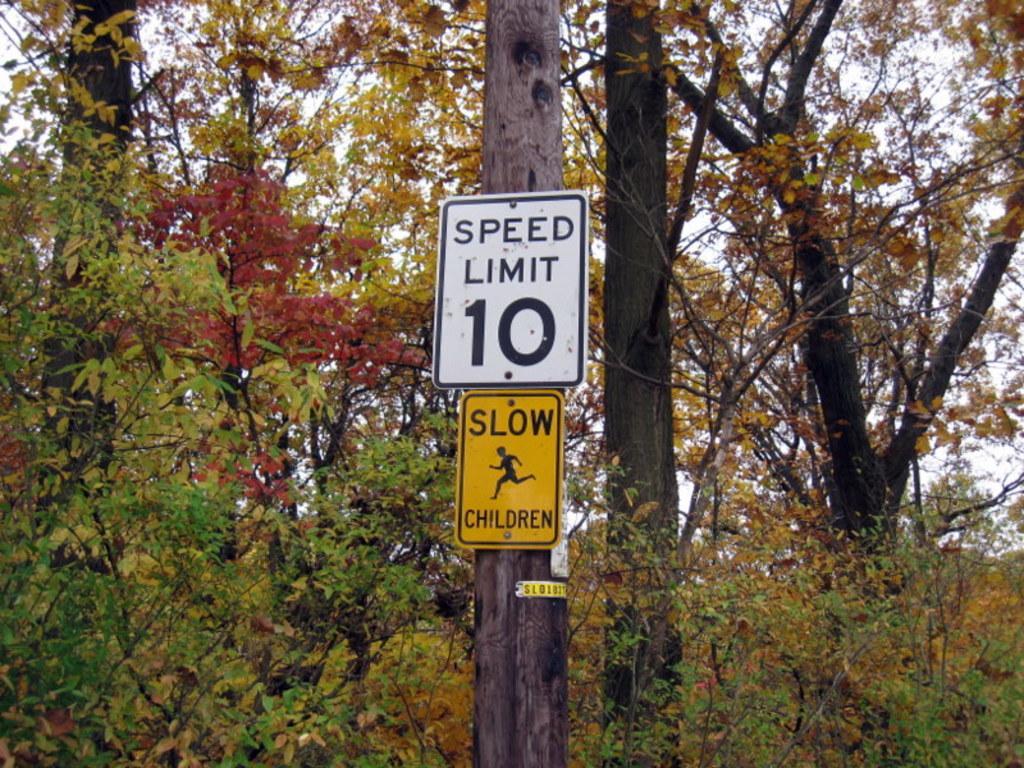Describe this image in one or two sentences. In this picture we can see a few sign boards on a tree trunk. There are some trees in the background. 